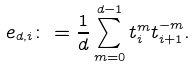Convert formula to latex. <formula><loc_0><loc_0><loc_500><loc_500>e _ { d , i } \colon = \frac { 1 } { d } \sum _ { m = 0 } ^ { d - 1 } t _ { i } ^ { m } t _ { i + 1 } ^ { - m } .</formula> 